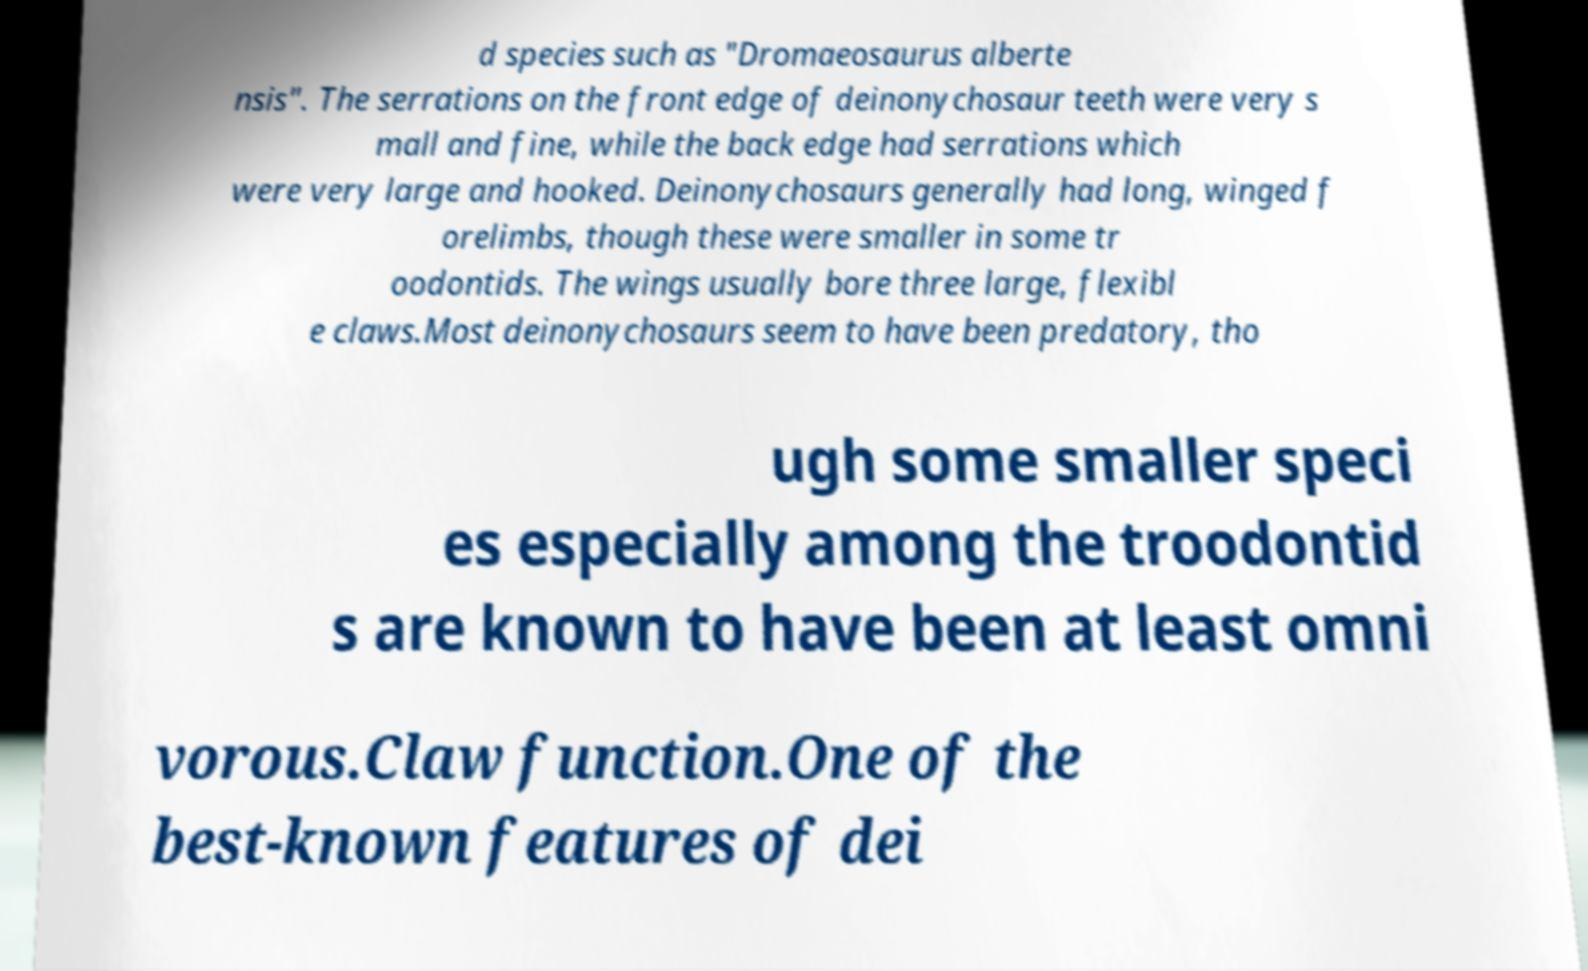What messages or text are displayed in this image? I need them in a readable, typed format. d species such as "Dromaeosaurus alberte nsis". The serrations on the front edge of deinonychosaur teeth were very s mall and fine, while the back edge had serrations which were very large and hooked. Deinonychosaurs generally had long, winged f orelimbs, though these were smaller in some tr oodontids. The wings usually bore three large, flexibl e claws.Most deinonychosaurs seem to have been predatory, tho ugh some smaller speci es especially among the troodontid s are known to have been at least omni vorous.Claw function.One of the best-known features of dei 